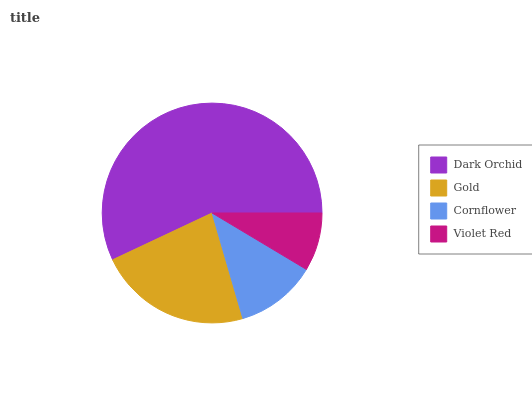Is Violet Red the minimum?
Answer yes or no. Yes. Is Dark Orchid the maximum?
Answer yes or no. Yes. Is Gold the minimum?
Answer yes or no. No. Is Gold the maximum?
Answer yes or no. No. Is Dark Orchid greater than Gold?
Answer yes or no. Yes. Is Gold less than Dark Orchid?
Answer yes or no. Yes. Is Gold greater than Dark Orchid?
Answer yes or no. No. Is Dark Orchid less than Gold?
Answer yes or no. No. Is Gold the high median?
Answer yes or no. Yes. Is Cornflower the low median?
Answer yes or no. Yes. Is Cornflower the high median?
Answer yes or no. No. Is Violet Red the low median?
Answer yes or no. No. 